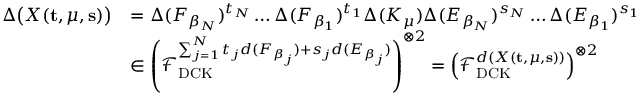Convert formula to latex. <formula><loc_0><loc_0><loc_500><loc_500>\begin{array} { r l } { \Delta \left ( X ( t , \mu , s ) \right ) } & { = \Delta ( F _ { \beta _ { N } } ) ^ { t _ { N } } \dots \Delta ( F _ { \beta _ { 1 } } ) ^ { t _ { 1 } } \Delta ( K _ { \mu } ) \Delta ( E _ { \beta _ { N } } ) ^ { s _ { N } } \dots \Delta ( E _ { \beta _ { 1 } } ) ^ { s _ { 1 } } } \\ & { \in \left ( \mathcal { F } _ { D C K } ^ { \sum _ { j = 1 } ^ { N } t _ { j } d ( F _ { \beta _ { j } } ) + s _ { j } d ( E _ { \beta _ { j } } ) } \right ) ^ { \otimes 2 } = \left ( \mathcal { F } _ { D C K } ^ { d ( X ( t , \mu , s ) ) } \right ) ^ { \otimes 2 } } \end{array}</formula> 